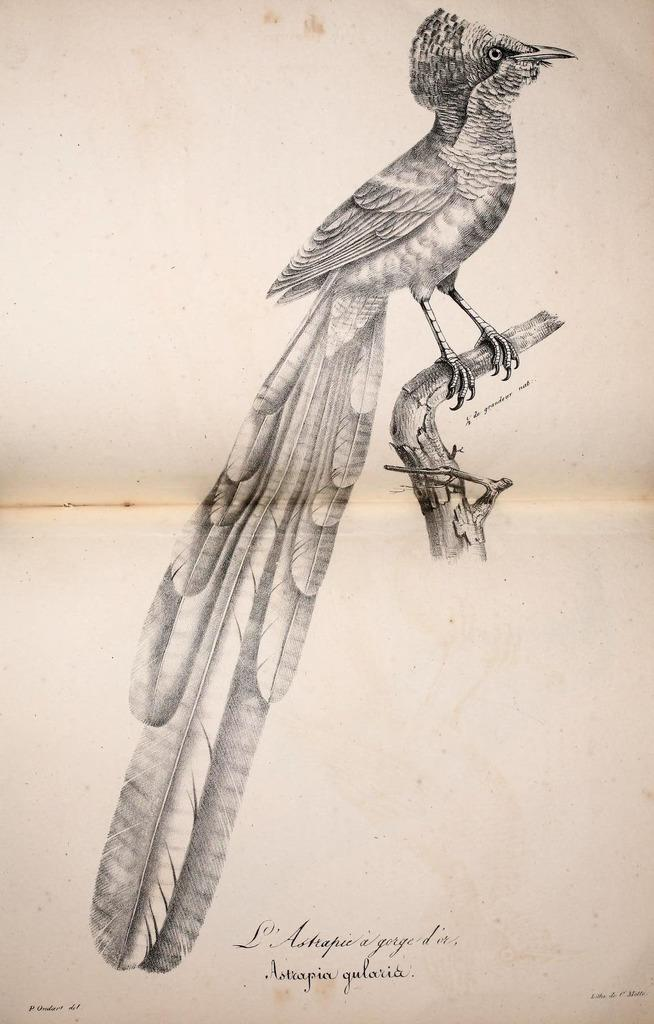What is depicted in the drawing in the image? There is a drawing of a bird in the image. Where is the bird located in the drawing? The bird is on a branch in the drawing. What additional information is provided at the bottom of the image? There is text at the bottom of the image. What type of plastic is used to create the quiver in the image? There is no quiver or plastic present in the image; it features a drawing of a bird on a branch with text at the bottom. 